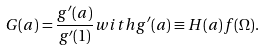<formula> <loc_0><loc_0><loc_500><loc_500>G ( a ) = \frac { g ^ { \prime } ( a ) } { g ^ { \prime } ( 1 ) } w i t h g ^ { \prime } ( a ) \equiv H ( a ) f ( \Omega ) .</formula> 